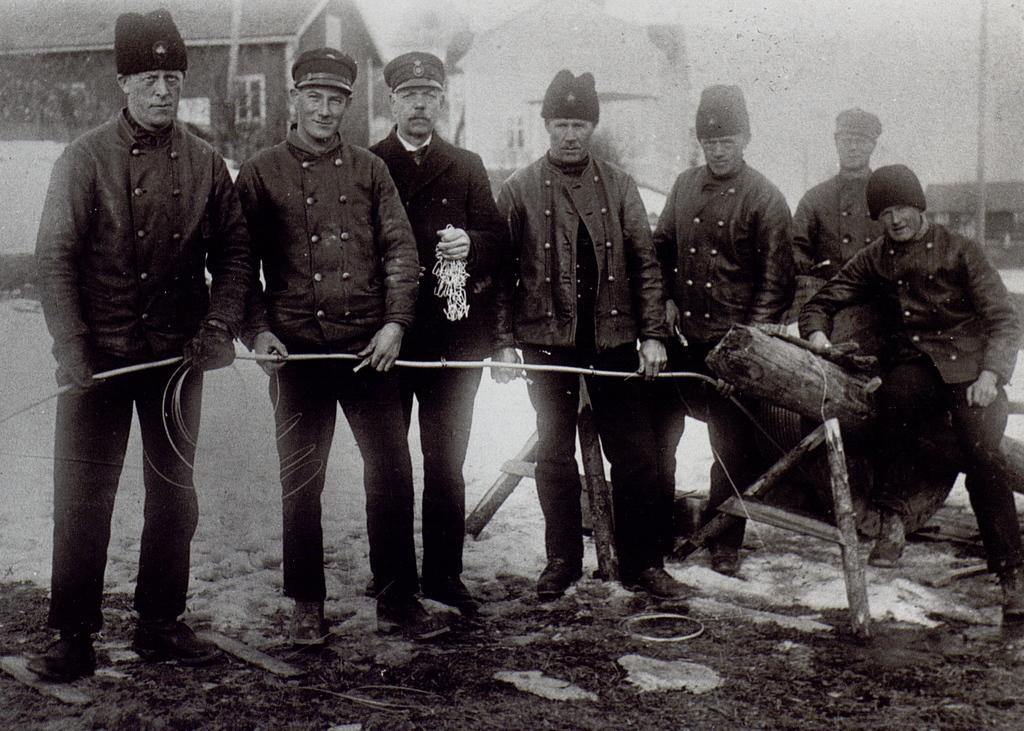What is the color scheme of the image? The image is black and white. What can be seen in the image? There is a group of people in the image. What are the people doing in the image? The people are holding a rope with their hands. What is visible in the background of the image? There are two houses in the background of the image. What type of sock is being worn by the person on the left side of the image? There is no sock visible in the image, as the image is black and white and does not show any clothing details. 